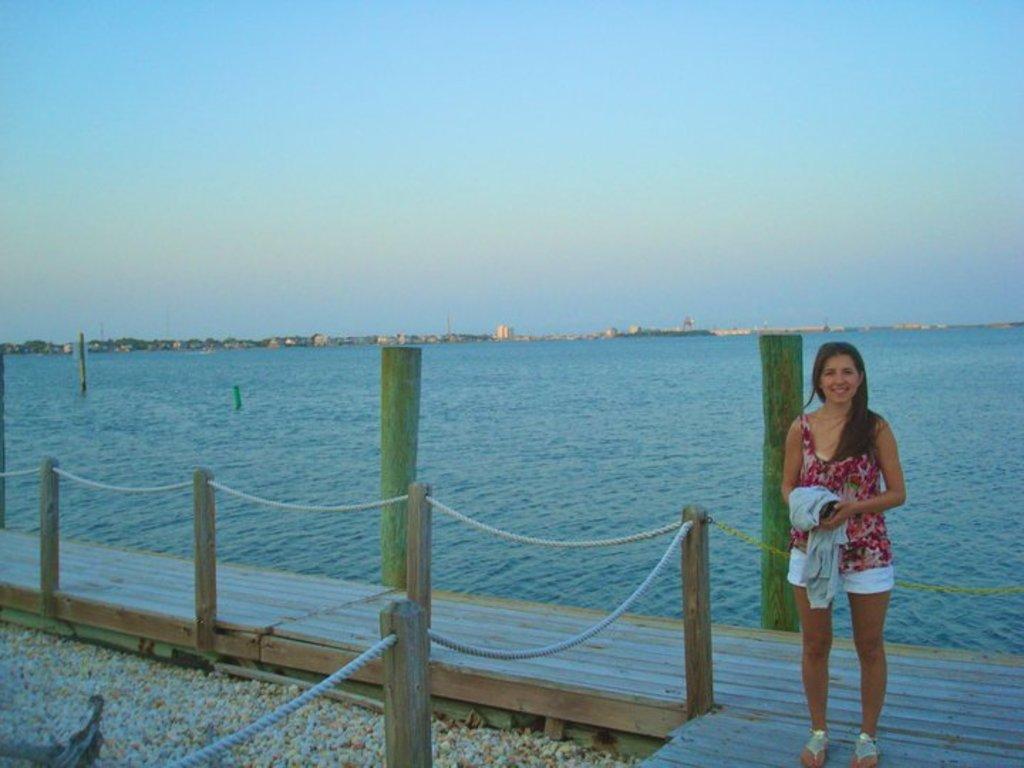In one or two sentences, can you explain what this image depicts? There is one woman standing on a dock and holding a jacket is on the right side of this image. We can see a surface of water in the middle of this image and the sky is in the background. 